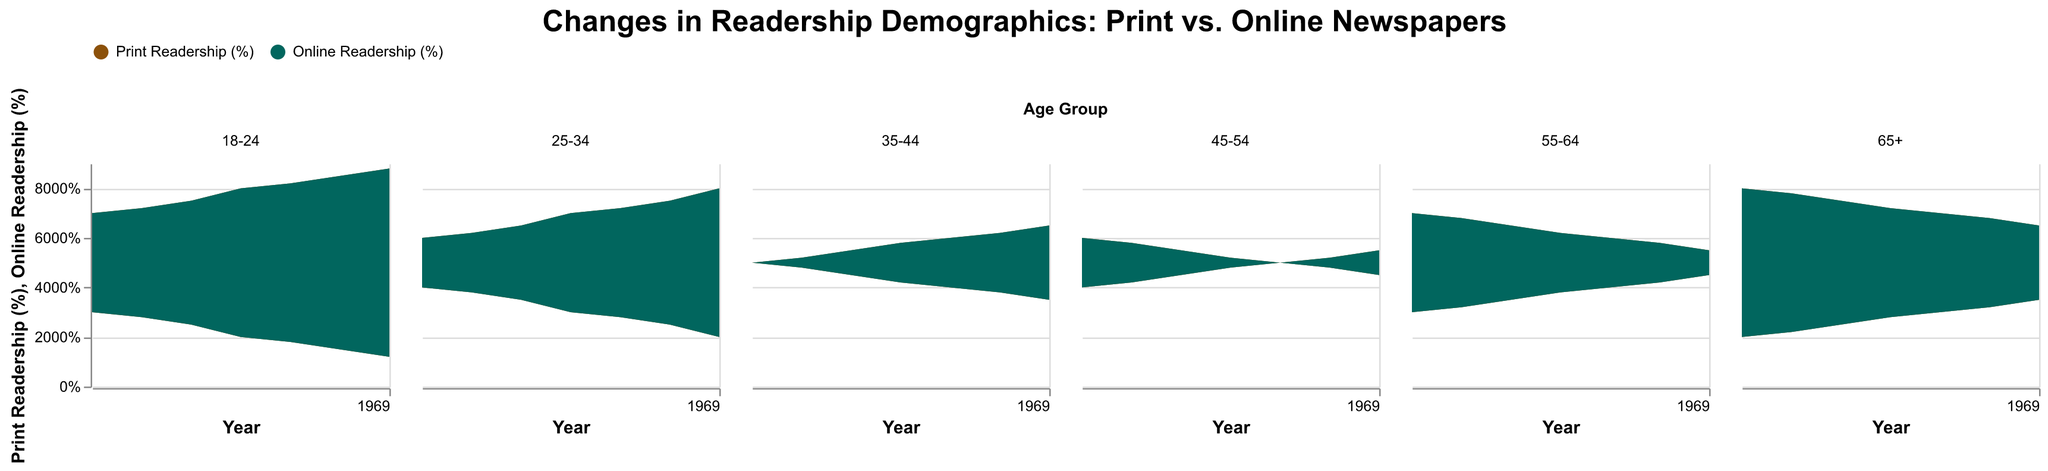What is the title of the figure? The title of the figure is given at the top, which states the main focus of the visual representation.
Answer: Changes in Readership Demographics: Print vs. Online Newspapers Which age group has the highest online readership in 2021? To find the age group with the highest online readership in 2021, look at the highest point in the Online Readership (%) area plot for the year 2021.
Answer: 18-24 How has the print readership for the 45-54 age group changed from 2015 to 2021? Examine the area plot for the 45-54 age group. Find the value of Print Readership (%) in 2015 and compare it with the value in 2021.
Answer: Decreased from 60% to 45% Which age group shows the slowest decline in print readership from 2015 to 2021? Compare the slopes of the print readership lines for each age group from 2015 to 2021 to identify the one with the least steep decline.
Answer: 65+ Between which years did the 25-34 age group see the largest increase in online readership? Look at the area plot for the 25-34 age group and find the years between which the Online Readership (%) increases the most.
Answer: 2017-2018 By how much did print readership for the 55-64 age group decrease between 2015 and 2021? Subtract the Print Readership (%) value in 2021 from the value in 2015 for the 55-64 age group.
Answer: 15% Which age group had an equal percentage of print and online readership in any given year? Look through each subplot to find an age group where the Print Readership (%) and Online Readership (%) intersect, leading to equal values.
Answer: 45-54 (in 2019) In which year did the 35-44 age group first have more online readership than print readership? Locate the point on the 35-44 age group's subplot where the Online Readership (%) surpasses the Print Readership (%) for the first time.
Answer: 2017 How does the trend in online readership compare between the 18-24 and 65+ age groups? Compare the slopes of the Online Readership (%) lines for the 18-24 and 65+ age groups across the years to determine their trends.
Answer: The 18-24 age group shows a steeper increase compared to the 65+ group What percentage of online readership did the 55-64 age group have in 2018? Locate the value on the Online Readership (%) area plot for the 55-64 age group in the year 2018.
Answer: 38% 